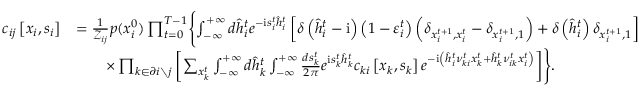<formula> <loc_0><loc_0><loc_500><loc_500>\begin{array} { r l } { c _ { i j } \left [ x _ { i } , s _ { i } \right ] } & { = \frac { 1 } { \mathcal { Z } _ { i j } } p ( x _ { i } ^ { 0 } ) \prod _ { t = 0 } ^ { T - 1 } \left \{ \int _ { - \infty } ^ { + \infty } d \hat { h } _ { i } ^ { t } e ^ { - i s _ { i } ^ { t } \hat { h } _ { i } ^ { t } } \left [ \delta \left ( \hat { h } _ { i } ^ { t } - i \right ) \left ( 1 - \varepsilon _ { i } ^ { t } \right ) \left ( \delta _ { x _ { i } ^ { t + 1 } , x _ { i } ^ { t } } - \delta _ { x _ { i } ^ { t + 1 } , 1 } \right ) + \delta \left ( \hat { h } _ { i } ^ { t } \right ) \delta _ { x _ { i } ^ { t + 1 } , 1 } \right ] } \\ & { \quad \times \prod _ { k \in \partial i \ j } \left [ \sum _ { x _ { k } ^ { t } } \int _ { - \infty } ^ { + \infty } d \hat { h } _ { k } ^ { t } \int _ { - \infty } ^ { + \infty } \frac { d s _ { k } ^ { t } } { 2 \pi } e ^ { i s _ { k } ^ { t } \hat { h } _ { k } ^ { t } } c _ { k i } \left [ x _ { k } , s _ { k } \right ] e ^ { - i \left ( \hat { h } _ { i } ^ { t } \nu _ { k i } ^ { t } x _ { k } ^ { t } + \hat { h } _ { k } ^ { t } \nu _ { i k } ^ { t } x _ { i } ^ { t } \right ) } \right ] \right \} . } \end{array}</formula> 